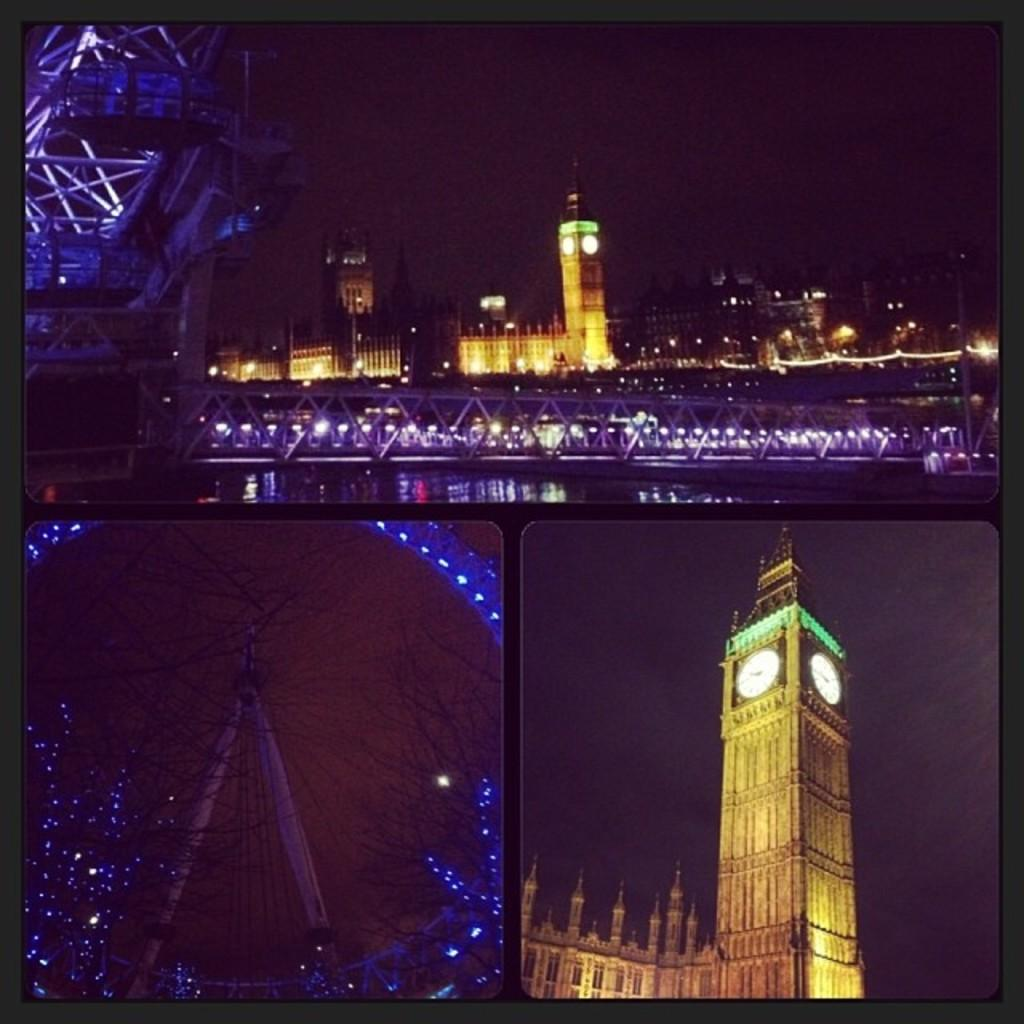What type of artwork is the image? The image is a collage. What structures can be seen in the collage? There is a tower and a bridge in the image. What type of feast is being prepared on the bridge in the image? There is no feast or any indication of food preparation in the image; it only features a tower and a bridge. 